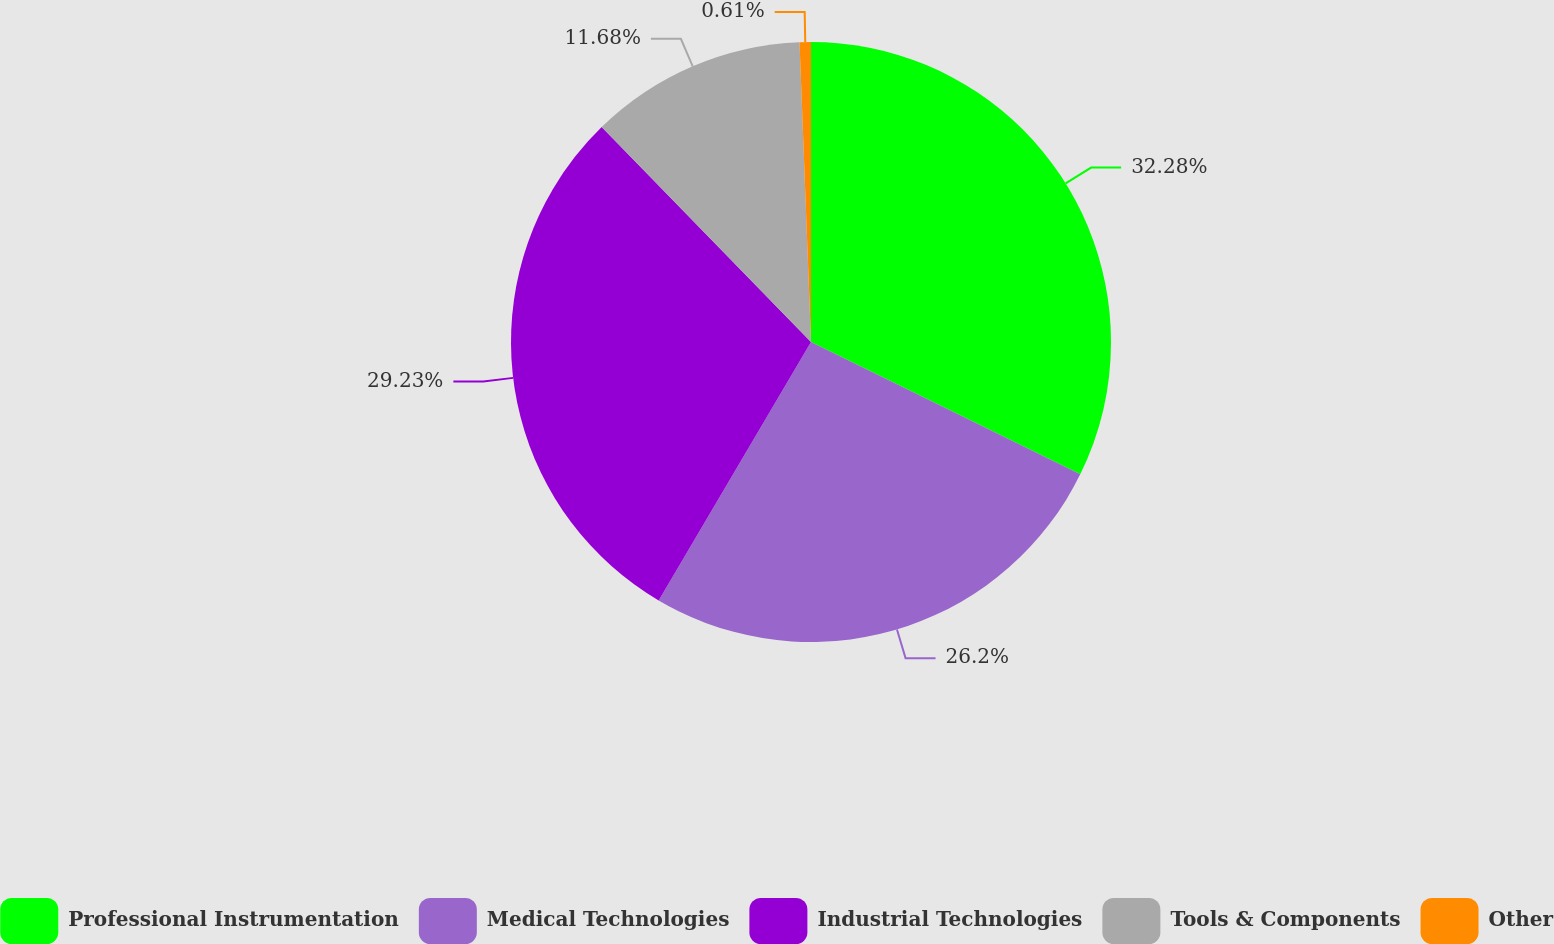Convert chart. <chart><loc_0><loc_0><loc_500><loc_500><pie_chart><fcel>Professional Instrumentation<fcel>Medical Technologies<fcel>Industrial Technologies<fcel>Tools & Components<fcel>Other<nl><fcel>32.27%<fcel>26.2%<fcel>29.23%<fcel>11.68%<fcel>0.61%<nl></chart> 